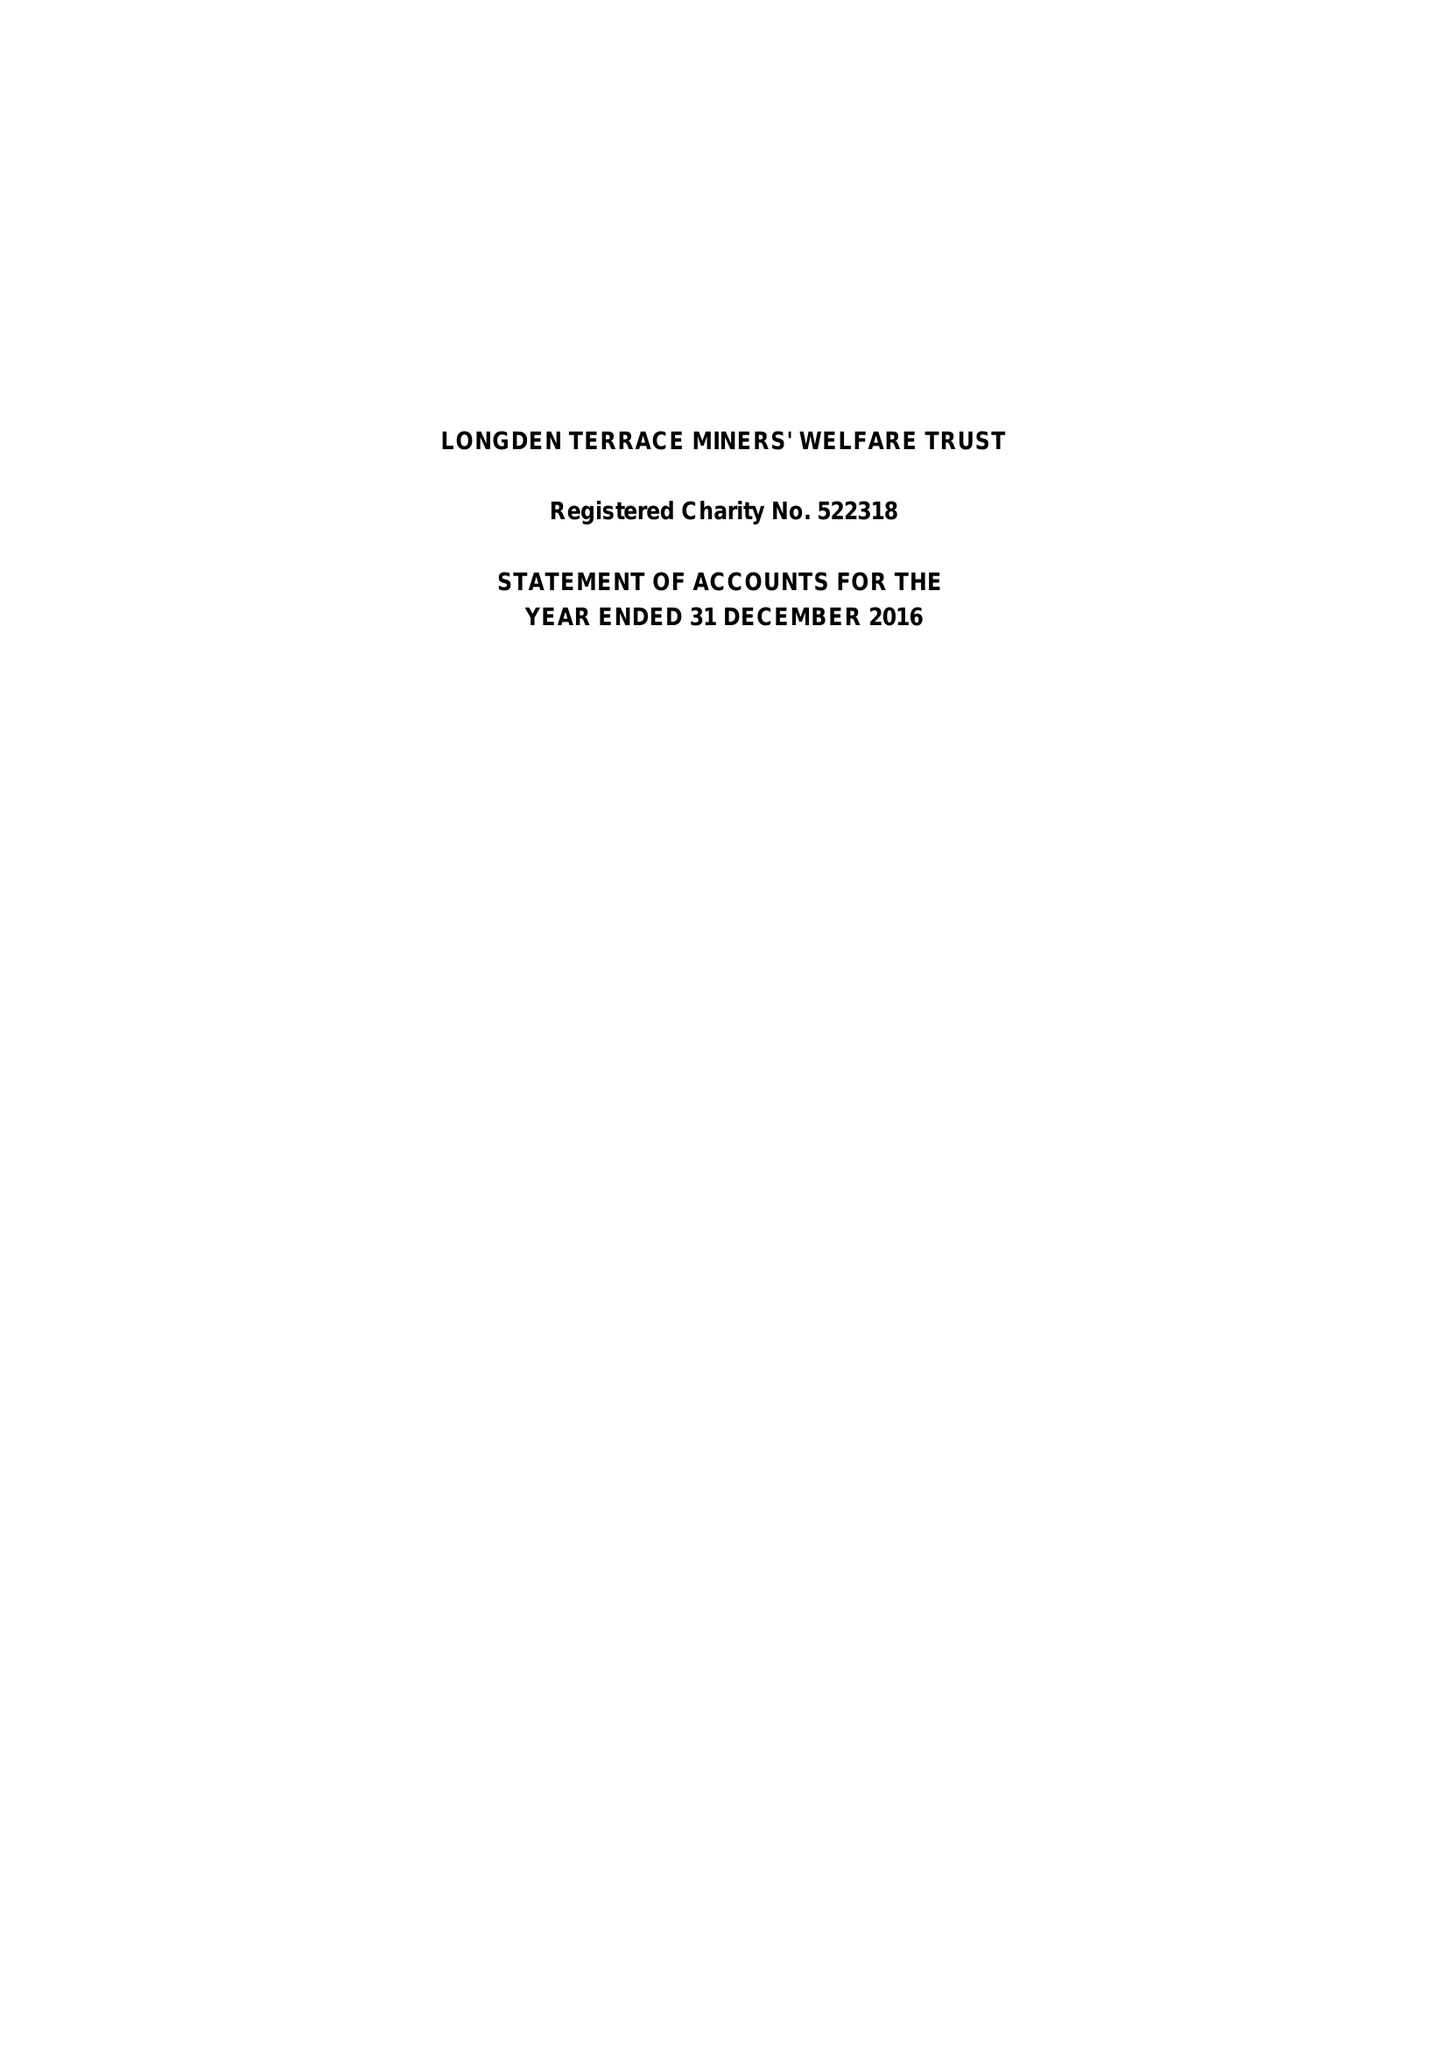What is the value for the income_annually_in_british_pounds?
Answer the question using a single word or phrase. 63954.00 